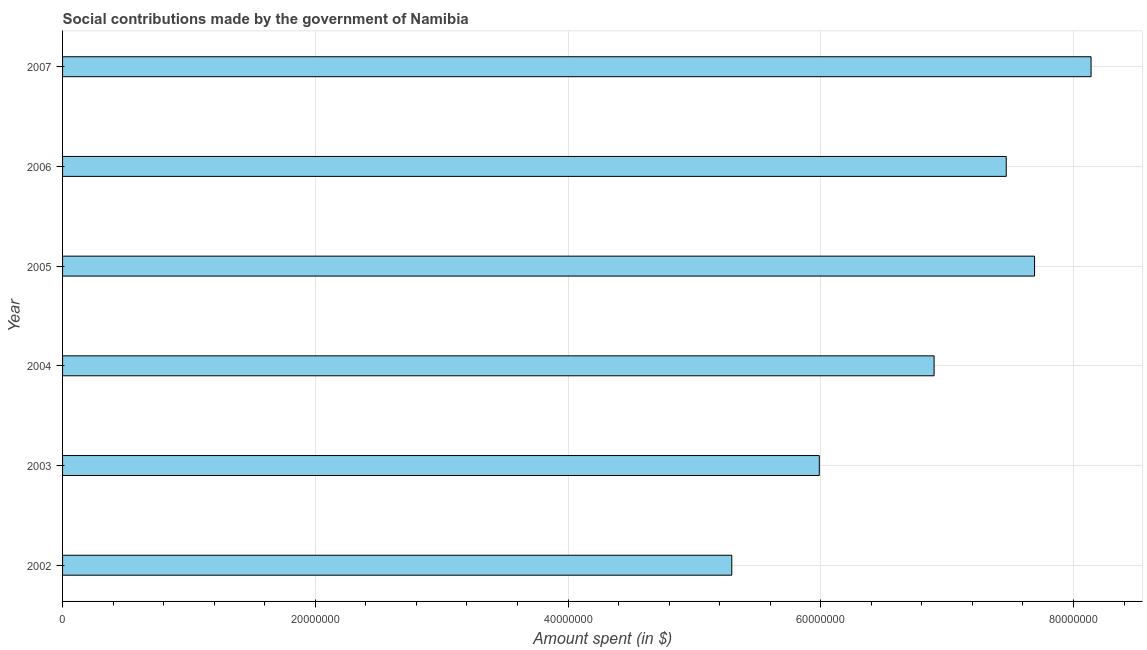Does the graph contain grids?
Provide a succinct answer. Yes. What is the title of the graph?
Your answer should be compact. Social contributions made by the government of Namibia. What is the label or title of the X-axis?
Offer a terse response. Amount spent (in $). What is the label or title of the Y-axis?
Your answer should be very brief. Year. What is the amount spent in making social contributions in 2003?
Offer a very short reply. 5.99e+07. Across all years, what is the maximum amount spent in making social contributions?
Your answer should be compact. 8.14e+07. Across all years, what is the minimum amount spent in making social contributions?
Ensure brevity in your answer.  5.30e+07. What is the sum of the amount spent in making social contributions?
Your answer should be compact. 4.15e+08. What is the difference between the amount spent in making social contributions in 2005 and 2006?
Keep it short and to the point. 2.24e+06. What is the average amount spent in making social contributions per year?
Provide a succinct answer. 6.91e+07. What is the median amount spent in making social contributions?
Your response must be concise. 7.18e+07. In how many years, is the amount spent in making social contributions greater than 68000000 $?
Give a very brief answer. 4. What is the ratio of the amount spent in making social contributions in 2002 to that in 2007?
Ensure brevity in your answer.  0.65. Is the difference between the amount spent in making social contributions in 2002 and 2004 greater than the difference between any two years?
Keep it short and to the point. No. What is the difference between the highest and the second highest amount spent in making social contributions?
Make the answer very short. 4.47e+06. What is the difference between the highest and the lowest amount spent in making social contributions?
Provide a succinct answer. 2.84e+07. How many bars are there?
Make the answer very short. 6. Are all the bars in the graph horizontal?
Make the answer very short. Yes. How many years are there in the graph?
Make the answer very short. 6. Are the values on the major ticks of X-axis written in scientific E-notation?
Make the answer very short. No. What is the Amount spent (in $) in 2002?
Your response must be concise. 5.30e+07. What is the Amount spent (in $) in 2003?
Offer a very short reply. 5.99e+07. What is the Amount spent (in $) in 2004?
Keep it short and to the point. 6.90e+07. What is the Amount spent (in $) of 2005?
Give a very brief answer. 7.69e+07. What is the Amount spent (in $) in 2006?
Keep it short and to the point. 7.47e+07. What is the Amount spent (in $) in 2007?
Your answer should be very brief. 8.14e+07. What is the difference between the Amount spent (in $) in 2002 and 2003?
Your response must be concise. -6.92e+06. What is the difference between the Amount spent (in $) in 2002 and 2004?
Keep it short and to the point. -1.60e+07. What is the difference between the Amount spent (in $) in 2002 and 2005?
Offer a very short reply. -2.40e+07. What is the difference between the Amount spent (in $) in 2002 and 2006?
Make the answer very short. -2.17e+07. What is the difference between the Amount spent (in $) in 2002 and 2007?
Keep it short and to the point. -2.84e+07. What is the difference between the Amount spent (in $) in 2003 and 2004?
Offer a very short reply. -9.08e+06. What is the difference between the Amount spent (in $) in 2003 and 2005?
Make the answer very short. -1.70e+07. What is the difference between the Amount spent (in $) in 2003 and 2006?
Provide a short and direct response. -1.48e+07. What is the difference between the Amount spent (in $) in 2003 and 2007?
Your answer should be very brief. -2.15e+07. What is the difference between the Amount spent (in $) in 2004 and 2005?
Offer a very short reply. -7.95e+06. What is the difference between the Amount spent (in $) in 2004 and 2006?
Ensure brevity in your answer.  -5.71e+06. What is the difference between the Amount spent (in $) in 2004 and 2007?
Keep it short and to the point. -1.24e+07. What is the difference between the Amount spent (in $) in 2005 and 2006?
Provide a succinct answer. 2.24e+06. What is the difference between the Amount spent (in $) in 2005 and 2007?
Offer a very short reply. -4.47e+06. What is the difference between the Amount spent (in $) in 2006 and 2007?
Provide a short and direct response. -6.71e+06. What is the ratio of the Amount spent (in $) in 2002 to that in 2003?
Ensure brevity in your answer.  0.88. What is the ratio of the Amount spent (in $) in 2002 to that in 2004?
Your answer should be compact. 0.77. What is the ratio of the Amount spent (in $) in 2002 to that in 2005?
Ensure brevity in your answer.  0.69. What is the ratio of the Amount spent (in $) in 2002 to that in 2006?
Provide a succinct answer. 0.71. What is the ratio of the Amount spent (in $) in 2002 to that in 2007?
Your answer should be compact. 0.65. What is the ratio of the Amount spent (in $) in 2003 to that in 2004?
Make the answer very short. 0.87. What is the ratio of the Amount spent (in $) in 2003 to that in 2005?
Your answer should be compact. 0.78. What is the ratio of the Amount spent (in $) in 2003 to that in 2006?
Ensure brevity in your answer.  0.8. What is the ratio of the Amount spent (in $) in 2003 to that in 2007?
Offer a very short reply. 0.74. What is the ratio of the Amount spent (in $) in 2004 to that in 2005?
Your response must be concise. 0.9. What is the ratio of the Amount spent (in $) in 2004 to that in 2006?
Your answer should be compact. 0.92. What is the ratio of the Amount spent (in $) in 2004 to that in 2007?
Keep it short and to the point. 0.85. What is the ratio of the Amount spent (in $) in 2005 to that in 2006?
Offer a very short reply. 1.03. What is the ratio of the Amount spent (in $) in 2005 to that in 2007?
Offer a very short reply. 0.94. What is the ratio of the Amount spent (in $) in 2006 to that in 2007?
Your answer should be very brief. 0.92. 